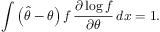Convert formula to latex. <formula><loc_0><loc_0><loc_500><loc_500>\int \left ( { \hat { \theta } } - \theta \right ) f \, { \frac { \partial \log f } { \partial \theta } } \, d x = 1 .</formula> 